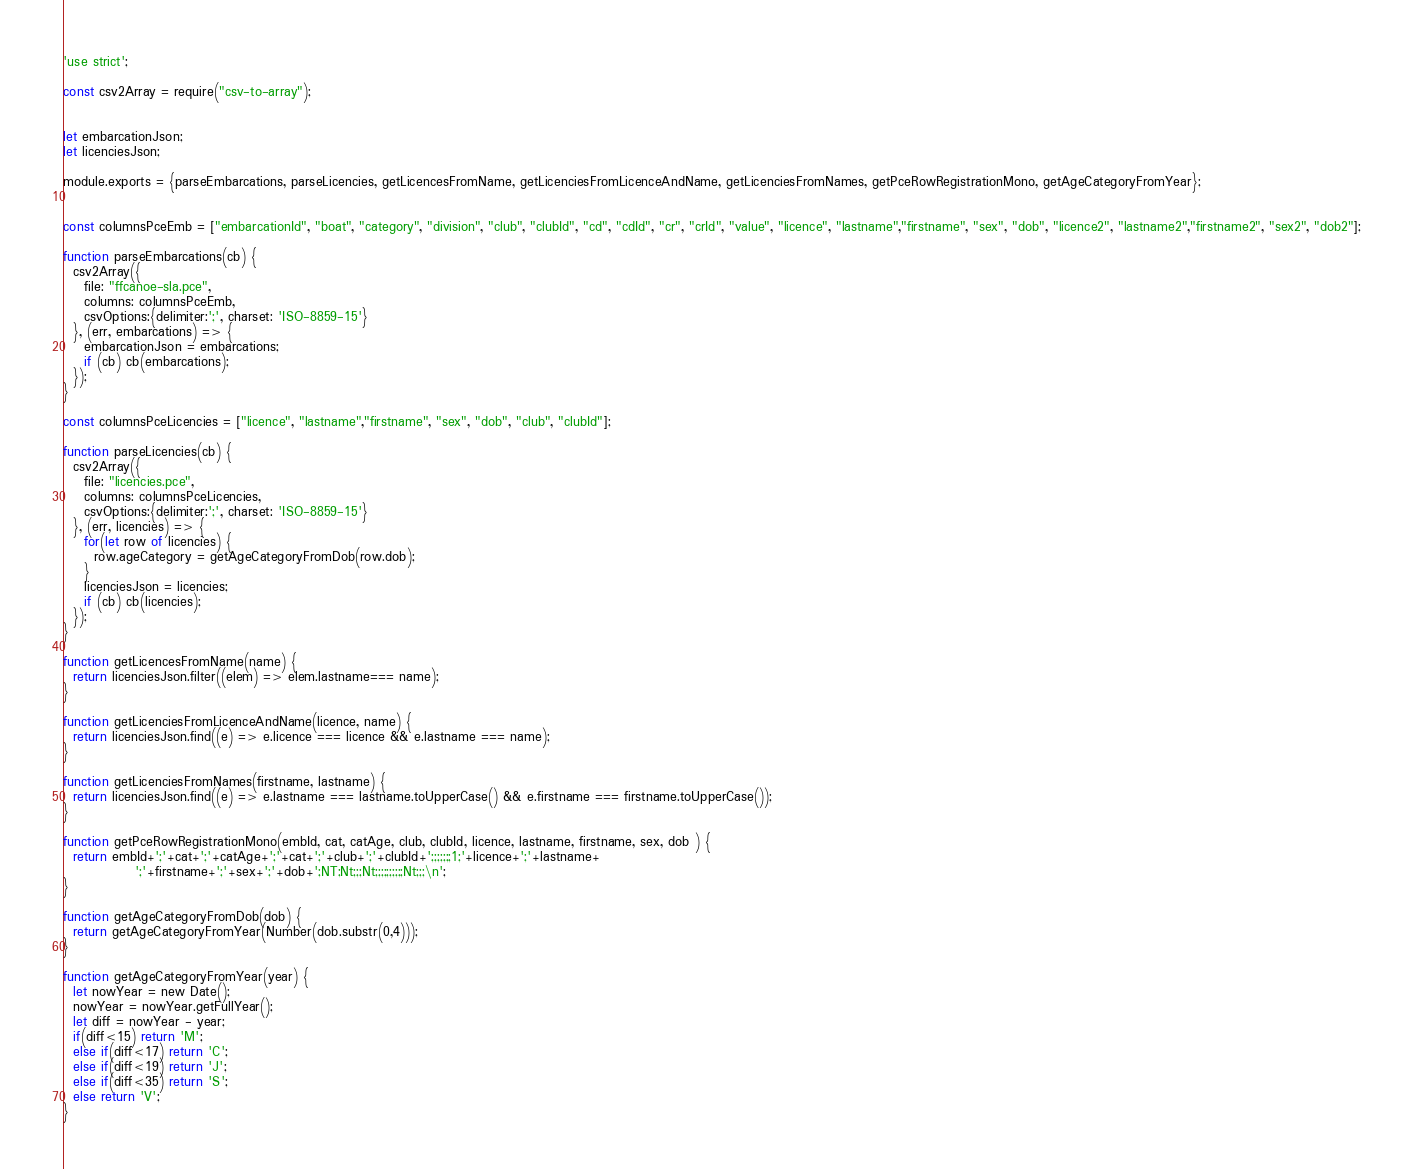<code> <loc_0><loc_0><loc_500><loc_500><_JavaScript_>'use strict';

const csv2Array = require("csv-to-array");


let embarcationJson;
let licenciesJson;

module.exports = {parseEmbarcations, parseLicencies, getLicencesFromName, getLicenciesFromLicenceAndName, getLicenciesFromNames, getPceRowRegistrationMono, getAgeCategoryFromYear};


const columnsPceEmb = ["embarcationId", "boat", "category", "division", "club", "clubId", "cd", "cdId", "cr", "crId", "value", "licence", "lastname","firstname", "sex", "dob", "licence2", "lastname2","firstname2", "sex2", "dob2"];

function parseEmbarcations(cb) {
  csv2Array({
    file: "ffcanoe-sla.pce",
    columns: columnsPceEmb,
    csvOptions:{delimiter:';', charset: 'ISO-8859-15'}
  }, (err, embarcations) => {
    embarcationJson = embarcations;
    if (cb) cb(embarcations);
  });
}

const columnsPceLicencies = ["licence", "lastname","firstname", "sex", "dob", "club", "clubId"];

function parseLicencies(cb) {
  csv2Array({
    file: "licencies.pce",
    columns: columnsPceLicencies,
    csvOptions:{delimiter:';', charset: 'ISO-8859-15'}
  }, (err, licencies) => {
    for(let row of licencies) {
      row.ageCategory = getAgeCategoryFromDob(row.dob);
    }
    licenciesJson = licencies;
    if (cb) cb(licencies);
  });
}

function getLicencesFromName(name) {
  return licenciesJson.filter((elem) => elem.lastname=== name);
} 

function getLicenciesFromLicenceAndName(licence, name) {
  return licenciesJson.find((e) => e.licence === licence && e.lastname === name);
}

function getLicenciesFromNames(firstname, lastname) {
  return licenciesJson.find((e) => e.lastname === lastname.toUpperCase() && e.firstname === firstname.toUpperCase());
}

function getPceRowRegistrationMono(embId, cat, catAge, club, clubId, licence, lastname, firstname, sex, dob ) {
  return embId+';'+cat+';'+catAge+';'+cat+';'+club+';'+clubId+';;;;;;;1;'+licence+';'+lastname+
              ';'+firstname+';'+sex+';'+dob+';NT;Nt;;;Nt;;;;;;;;;;Nt;;;\n';
}

function getAgeCategoryFromDob(dob) {
  return getAgeCategoryFromYear(Number(dob.substr(0,4)));
}

function getAgeCategoryFromYear(year) {
  let nowYear = new Date();
  nowYear = nowYear.getFullYear();
  let diff = nowYear - year;
  if(diff<15) return 'M';
  else if(diff<17) return 'C';
  else if(diff<19) return 'J';
  else if(diff<35) return 'S';
  else return 'V';
}</code> 